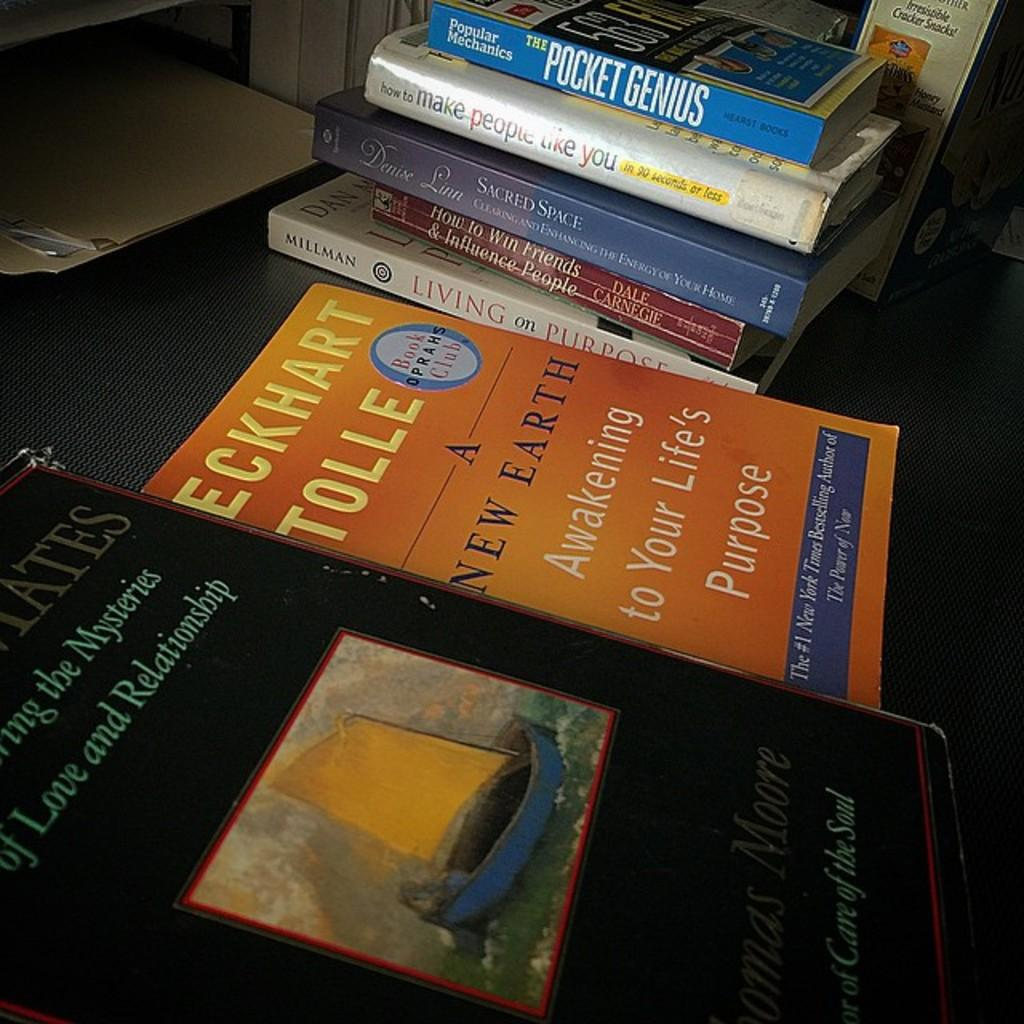<image>
Give a short and clear explanation of the subsequent image. A collection of self help and personal improvement books by people like Dale Carnegie and Eckhart Tolle are displayed on a table. 